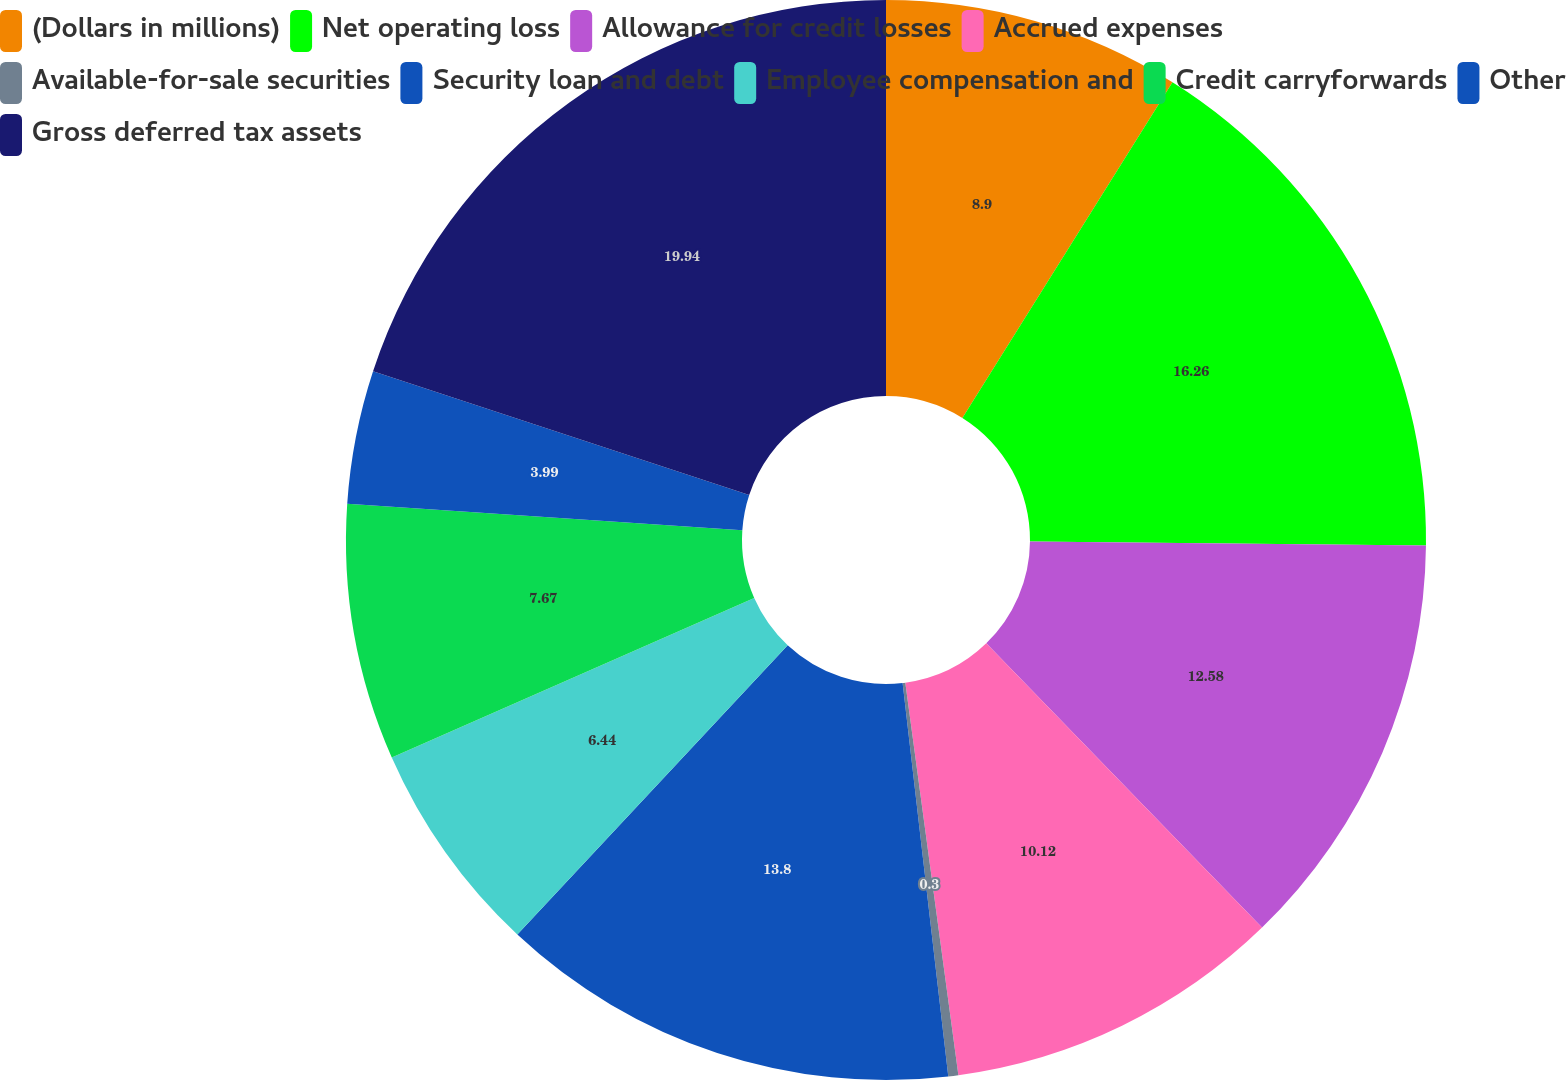<chart> <loc_0><loc_0><loc_500><loc_500><pie_chart><fcel>(Dollars in millions)<fcel>Net operating loss<fcel>Allowance for credit losses<fcel>Accrued expenses<fcel>Available-for-sale securities<fcel>Security loan and debt<fcel>Employee compensation and<fcel>Credit carryforwards<fcel>Other<fcel>Gross deferred tax assets<nl><fcel>8.9%<fcel>16.26%<fcel>12.58%<fcel>10.12%<fcel>0.3%<fcel>13.8%<fcel>6.44%<fcel>7.67%<fcel>3.99%<fcel>19.94%<nl></chart> 